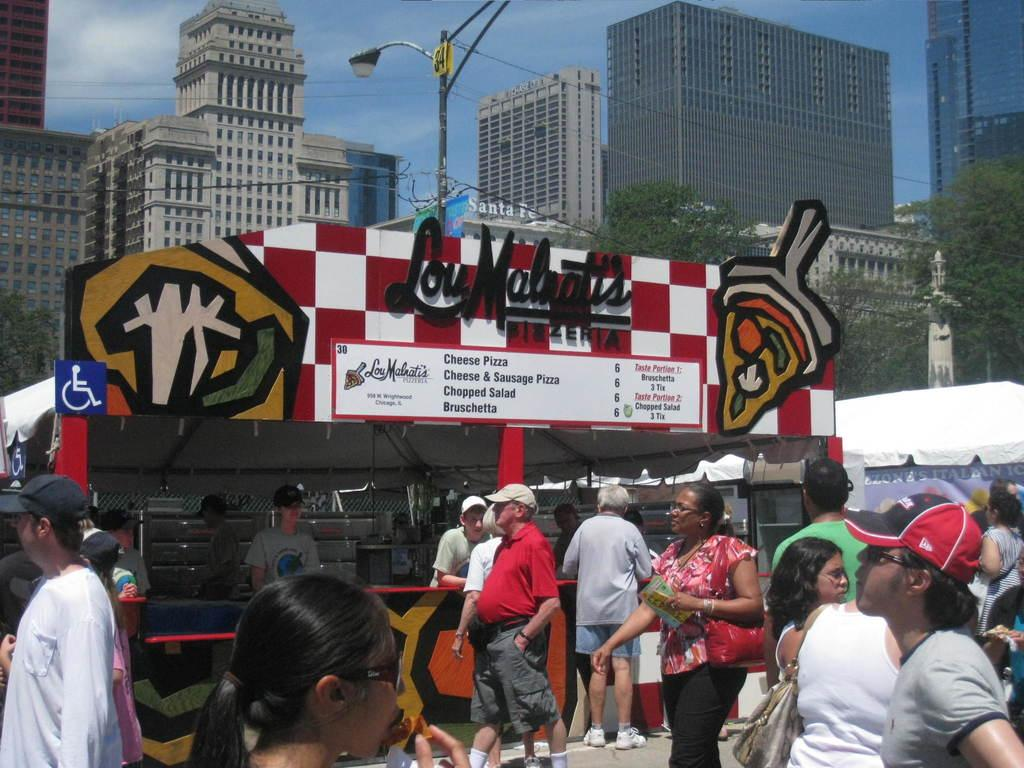What is the main subject in the foreground of the picture? There is a group of people in the foreground of the picture. What can be seen in the center of the picture? There is a street light, cables, and a shop in the center of the picture. What type of buildings are visible in the background of the picture? There are skyscrapers in the background of the picture. What is visible in the sky in the background of the picture? The sky is visible in the background of the picture. Can you see a locket hanging from the street light in the picture? No, there is no locket hanging from the street light in the picture. Is there a ship sailing in the sky in the background of the picture? No, there is no ship sailing in the sky in the background of the picture. 